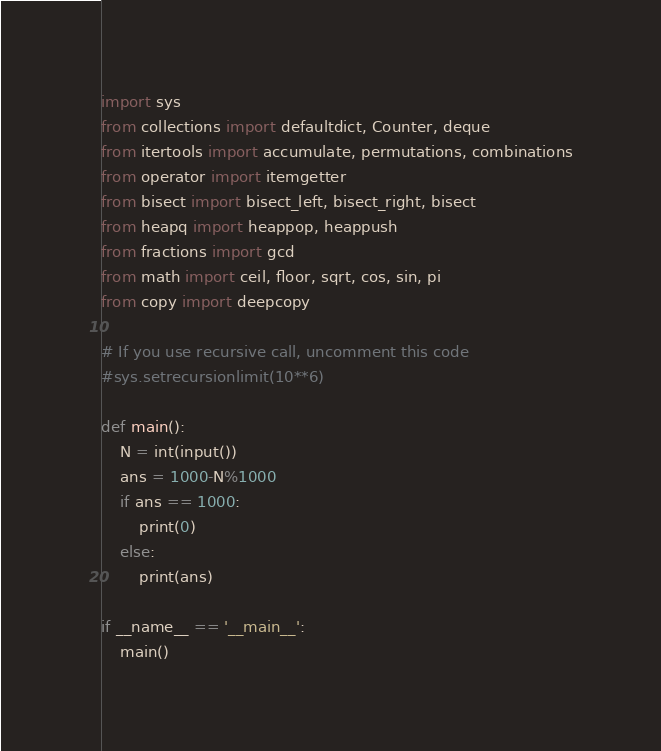Convert code to text. <code><loc_0><loc_0><loc_500><loc_500><_Python_>import sys
from collections import defaultdict, Counter, deque
from itertools import accumulate, permutations, combinations
from operator import itemgetter
from bisect import bisect_left, bisect_right, bisect
from heapq import heappop, heappush
from fractions import gcd
from math import ceil, floor, sqrt, cos, sin, pi
from copy import deepcopy

# If you use recursive call, uncomment this code
#sys.setrecursionlimit(10**6)

def main():
    N = int(input())
    ans = 1000-N%1000
    if ans == 1000:
        print(0)
    else:
        print(ans)

if __name__ == '__main__':
    main()
</code> 